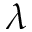Convert formula to latex. <formula><loc_0><loc_0><loc_500><loc_500>\lambda</formula> 